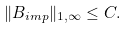Convert formula to latex. <formula><loc_0><loc_0><loc_500><loc_500>\| B _ { i m p } \| _ { 1 , \infty } \leq C .</formula> 